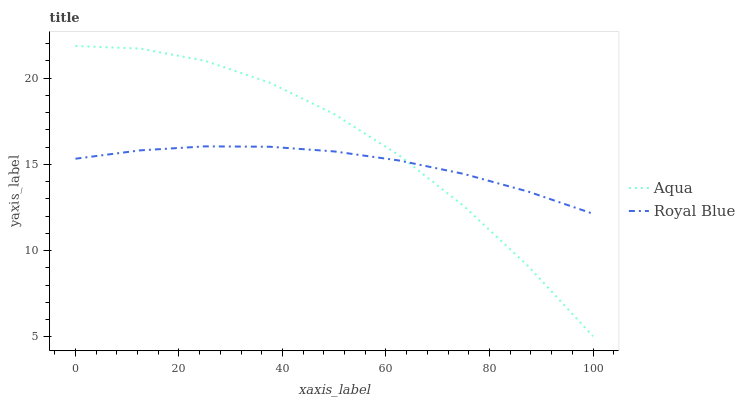Does Royal Blue have the minimum area under the curve?
Answer yes or no. Yes. Does Aqua have the maximum area under the curve?
Answer yes or no. Yes. Does Aqua have the minimum area under the curve?
Answer yes or no. No. Is Royal Blue the smoothest?
Answer yes or no. Yes. Is Aqua the roughest?
Answer yes or no. Yes. Is Aqua the smoothest?
Answer yes or no. No. Does Aqua have the lowest value?
Answer yes or no. Yes. Does Aqua have the highest value?
Answer yes or no. Yes. Does Royal Blue intersect Aqua?
Answer yes or no. Yes. Is Royal Blue less than Aqua?
Answer yes or no. No. Is Royal Blue greater than Aqua?
Answer yes or no. No. 